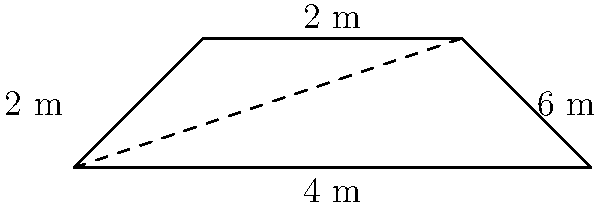A city planner is designing a new speed bump to improve road safety. The speed bump has a trapezoidal cross-section with parallel sides of 6 m and 2 m, and a height of 2 m. What is the area of the trapezoidal cross-section of the speed bump? To find the area of a trapezoid, we can use the formula:

$$A = \frac{1}{2}(b_1 + b_2)h$$

Where:
$A$ = area
$b_1$ and $b_2$ = lengths of the parallel sides
$h$ = height

Given:
$b_1 = 6$ m (longer parallel side)
$b_2 = 2$ m (shorter parallel side)
$h = 2$ m (height)

Let's substitute these values into the formula:

$$A = \frac{1}{2}(6 \text{ m} + 2 \text{ m}) \times 2 \text{ m}$$

$$A = \frac{1}{2}(8 \text{ m}) \times 2 \text{ m}$$

$$A = 4 \text{ m} \times 2 \text{ m}$$

$$A = 8 \text{ m}^2$$

Therefore, the area of the trapezoidal cross-section of the speed bump is 8 square meters.
Answer: 8 m² 